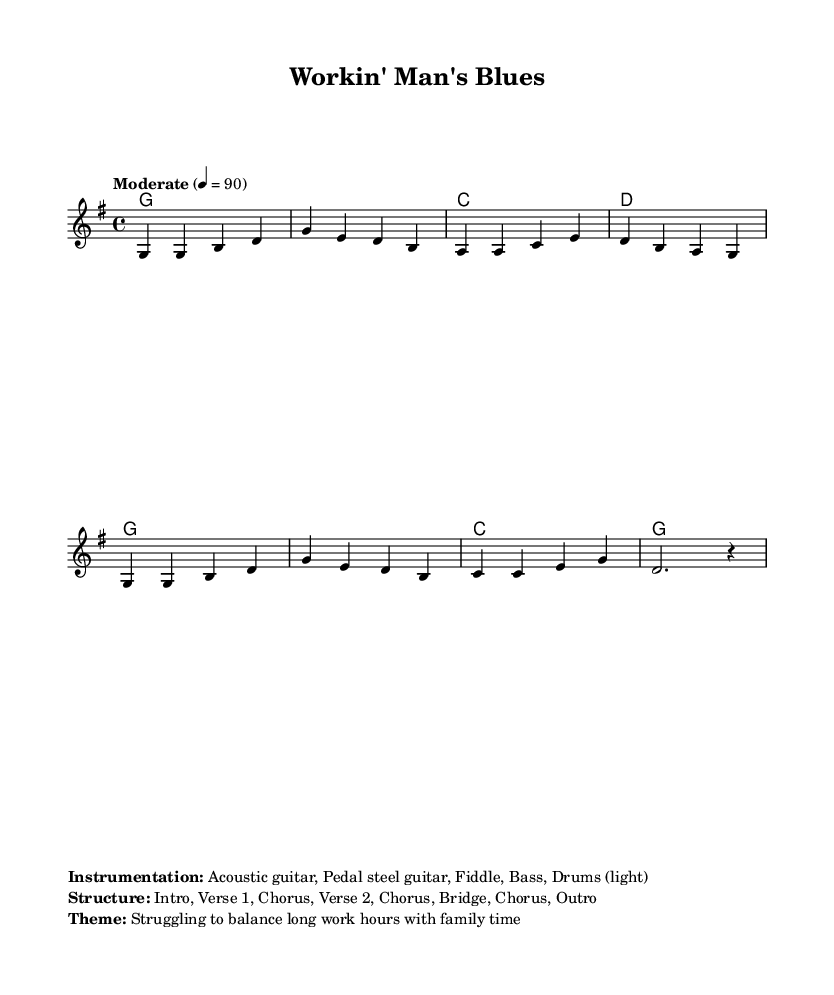What is the key signature of this music? The key signature can be found at the beginning of the staff, which indicates that there is an 'F#' and 'C#' that are being used, thus establishing it as G major with an 'F#' and no other sharps or flats.
Answer: G major What is the time signature of this music? The time signature is typically shown after the key signature at the beginning of the staff, which displays '4/4', meaning four beats per measure.
Answer: 4/4 What is the tempo marking of this music? The tempo marking is indicated in the score, noting "Moderate" with a tempo of 90 beats per minute, which helps define the speed of the performance.
Answer: Moderate What is the structure of the piece? The structure is detailed in the markup section and consists of an Intro, Verse 1, Chorus, Verse 2, Chorus, Bridge, Chorus, and Outro, outlining the layout of the song.
Answer: Intro, Verse 1, Chorus, Verse 2, Chorus, Bridge, Chorus, Outro What instruments are featured in this piece? The instrumentation is specified in the markup section, listing Acoustic guitar, Pedal steel guitar, Fiddle, Bass, and Drums as the instruments used, reflecting typical Country music arrangements.
Answer: Acoustic guitar, Pedal steel guitar, Fiddle, Bass, Drums What is the primary theme of the song? The theme is described in the markup section as struggling to balance long work hours with family time, which resonates with common narratives in Country music.
Answer: Struggling to balance work and family How many chords are used in the harmonic progression? The chord progression in the harmonies can be counted, noting each unique chord throughout the piece 'g', 'c', 'd', hence totaling four distinct chords.
Answer: Four 